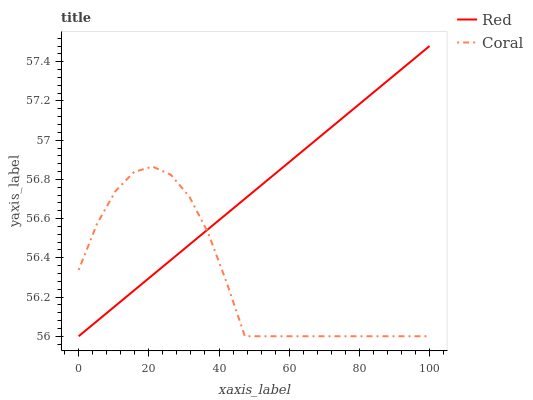Does Coral have the minimum area under the curve?
Answer yes or no. Yes. Does Red have the maximum area under the curve?
Answer yes or no. Yes. Does Red have the minimum area under the curve?
Answer yes or no. No. Is Red the smoothest?
Answer yes or no. Yes. Is Coral the roughest?
Answer yes or no. Yes. Is Red the roughest?
Answer yes or no. No. Does Coral have the lowest value?
Answer yes or no. Yes. Does Red have the highest value?
Answer yes or no. Yes. Does Red intersect Coral?
Answer yes or no. Yes. Is Red less than Coral?
Answer yes or no. No. Is Red greater than Coral?
Answer yes or no. No. 